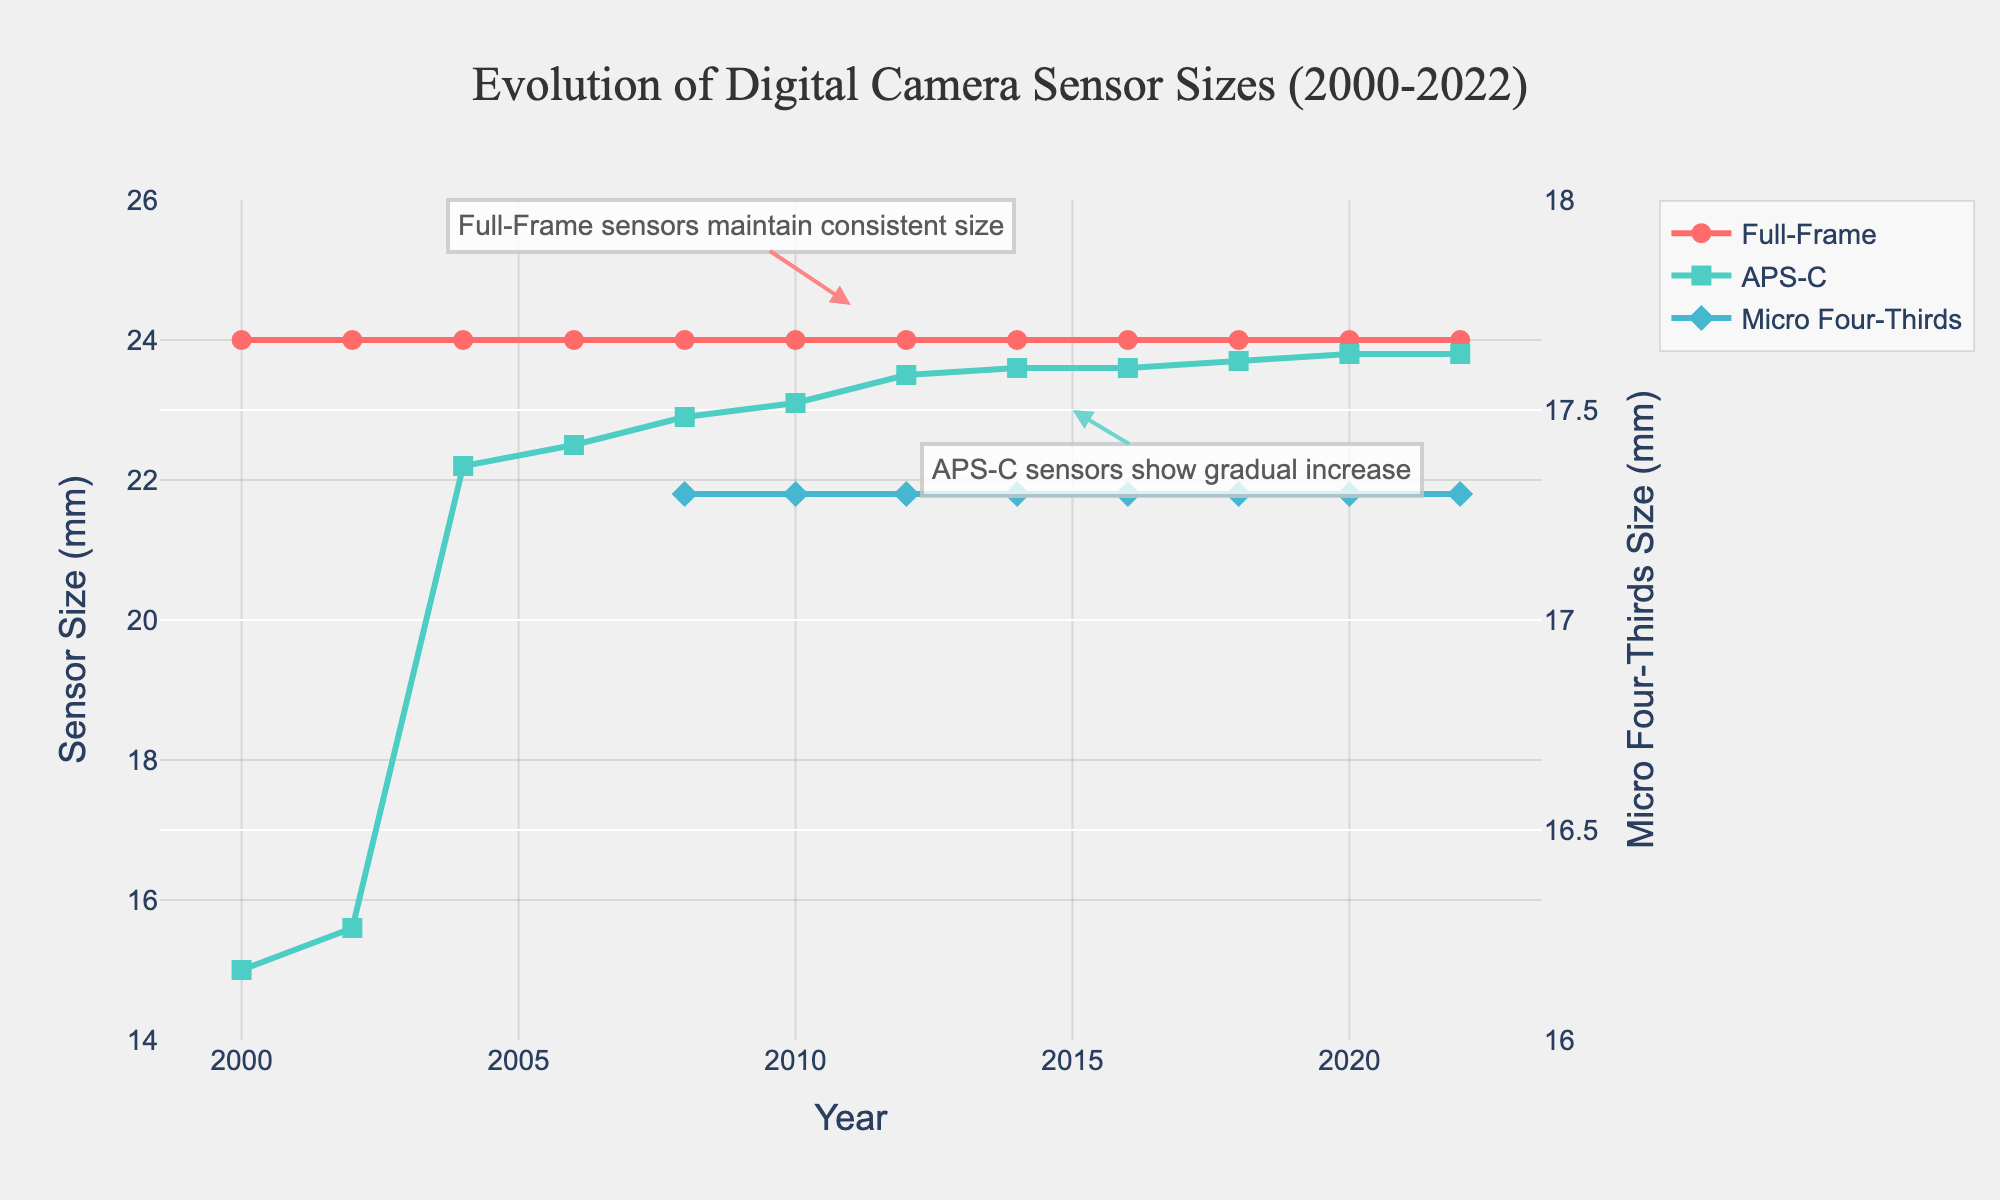How has the full-frame sensor size changed from 2000 to 2022? By observing the red line representing full-frame sensors on the chart, we can see it remains constant at 24 mm from 2000 to 2022. So, the full-frame sensor size has not changed over this period.
Answer: It has not changed Which sensor type shows the most noticeable trend over the years? By looking at the slopes of the lines, APS-C sensors (green line) display a noticeable upward trend, indicating a gradual increase in size. In contrast, the other sensors show either a constant value or a stable trend after introduction.
Answer: APS-C What's the difference in APS-C sensor sizes between 2004 and 2022? The APS-C size in 2004 is approximately 22.2 mm, and in 2022 it is approximately 23.8 mm. The difference is calculated as 23.8 mm - 22.2 mm = 1.6 mm.
Answer: 1.6 mm How does the range of micro four-thirds sensor sizes compare to the range of full-frame sensor sizes? The range for micro four-thirds sensors is calculated between 17.3 mm (minimum) and 17.3 mm (maximum), resulting in a range of 0 mm. For full-frame sensors, the range is between 24 mm (minimum) and 24 mm (maximum), also resulting in a range of 0 mm. Both ranges are 0 mm, indicating no variation.
Answer: Both ranges are 0 mm Which year did micro four-thirds sensors first appear on the chart? By examining the micro four-thirds line (blue line) on the chart, we notice its first appearance in 2008.
Answer: 2008 Calculate the average size of APS-C sensors from 2008 to 2022. The sizes are 22.9 mm (2008), 23.1 mm (2010), 23.5 mm (2012), 23.6 mm (2014), 23.6 mm (2016), 23.7 mm (2018), 23.8 mm (2020), and 23.8 mm (2022). The sum is 188.0 mm; the count is 8. The average is 188.0 mm / 8 = 23.5 mm.
Answer: 23.5 mm How many times does the full-frame sensor size feature in an annotation? The annotation explicitly talking about full-frame sensors mentions "Full-Frame sensors maintain consistent size" at around 2011. There's only one annotation related to full-frame sensor size.
Answer: Once Which sensor type is always mentioned on the secondary y-axis? Reading the secondary y-axis label, it mentions "Micro Four-Thirds Size (mm)", indicating it exclusively represents micro four-thirds sensor sizes over time.
Answer: Micro Four-Thirds Identify the highest value for APS-C sensor size and the corresponding year. The highest value on the green line for APS-C sensors is 23.8 mm. By following the line, this value is reached in 2020 and 2022.
Answer: 23.8 mm in 2020 and 2022 